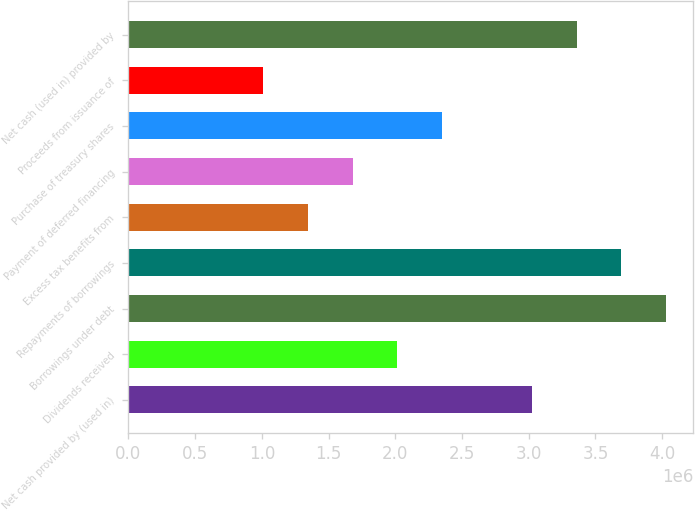Convert chart to OTSL. <chart><loc_0><loc_0><loc_500><loc_500><bar_chart><fcel>Net cash provided by (used in)<fcel>Dividends received<fcel>Borrowings under debt<fcel>Repayments of borrowings<fcel>Excess tax benefits from<fcel>Payment of deferred financing<fcel>Purchase of treasury shares<fcel>Proceeds from issuance of<fcel>Net cash (used in) provided by<nl><fcel>3.02225e+06<fcel>2.01501e+06<fcel>4.02949e+06<fcel>3.69375e+06<fcel>1.34352e+06<fcel>1.67927e+06<fcel>2.35076e+06<fcel>1.00777e+06<fcel>3.358e+06<nl></chart> 